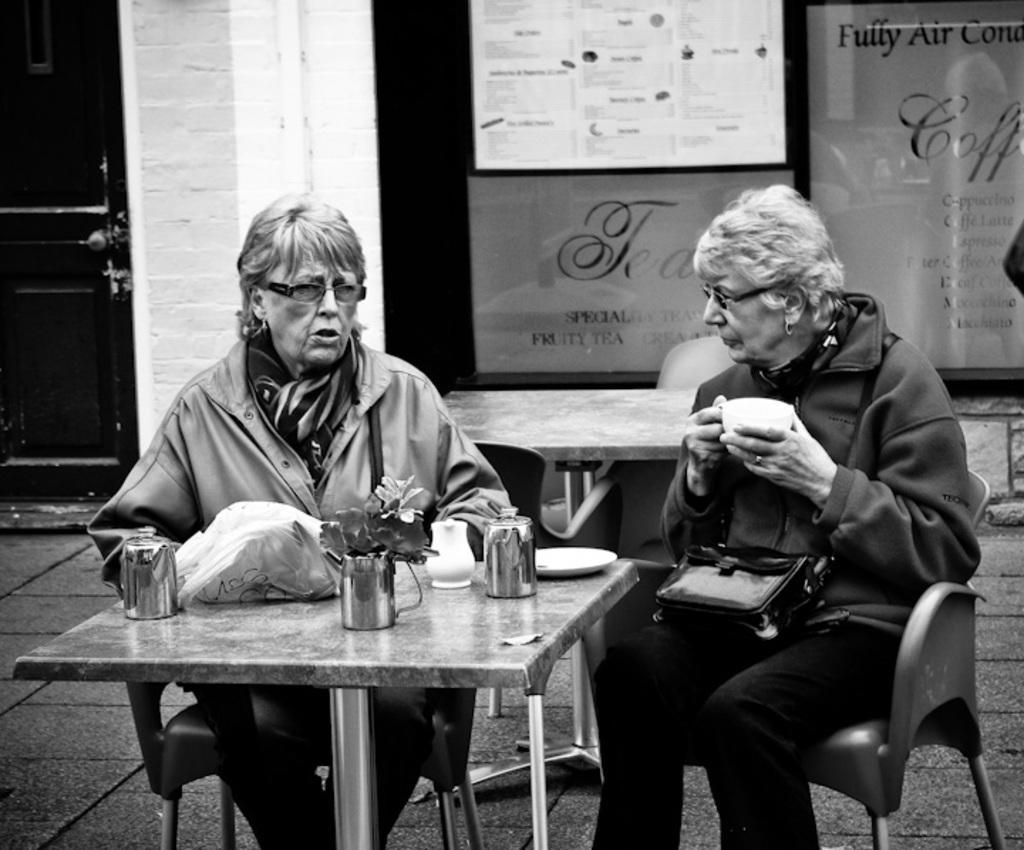In one or two sentences, can you explain what this image depicts? In this image i can see there are the two women sitting on the chair and on the right side woman holding a cap and left side woman her mouth was open and she wearing a spectacles and in front her there is a table and there is a plant on the cup there is a saucer and back side on the left there is a door. on the middle there is a hoarding board. 